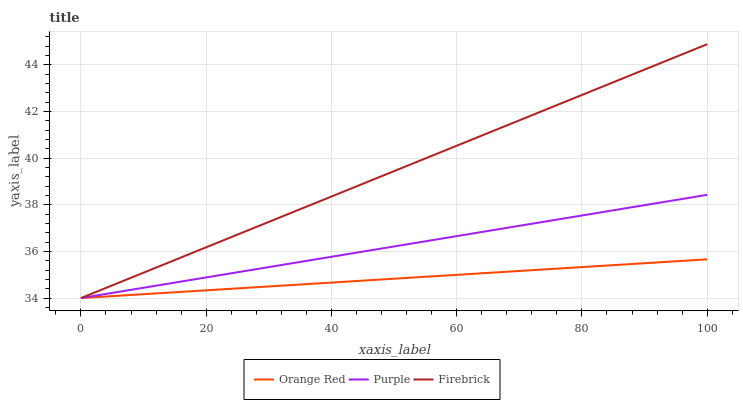Does Orange Red have the minimum area under the curve?
Answer yes or no. Yes. Does Firebrick have the maximum area under the curve?
Answer yes or no. Yes. Does Firebrick have the minimum area under the curve?
Answer yes or no. No. Does Orange Red have the maximum area under the curve?
Answer yes or no. No. Is Purple the smoothest?
Answer yes or no. Yes. Is Firebrick the roughest?
Answer yes or no. Yes. Is Firebrick the smoothest?
Answer yes or no. No. Is Orange Red the roughest?
Answer yes or no. No. Does Firebrick have the highest value?
Answer yes or no. Yes. Does Orange Red have the highest value?
Answer yes or no. No. Does Orange Red intersect Firebrick?
Answer yes or no. Yes. Is Orange Red less than Firebrick?
Answer yes or no. No. Is Orange Red greater than Firebrick?
Answer yes or no. No. 